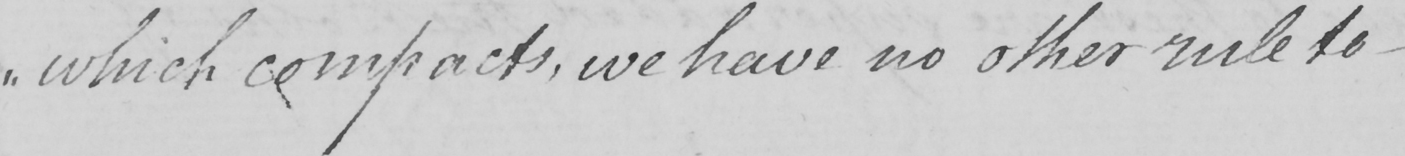Please transcribe the handwritten text in this image. " which compacts , we have no other rule to  _ 